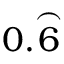<formula> <loc_0><loc_0><loc_500><loc_500>0 . { \overset { \frown } { 6 } }</formula> 